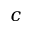<formula> <loc_0><loc_0><loc_500><loc_500>c</formula> 